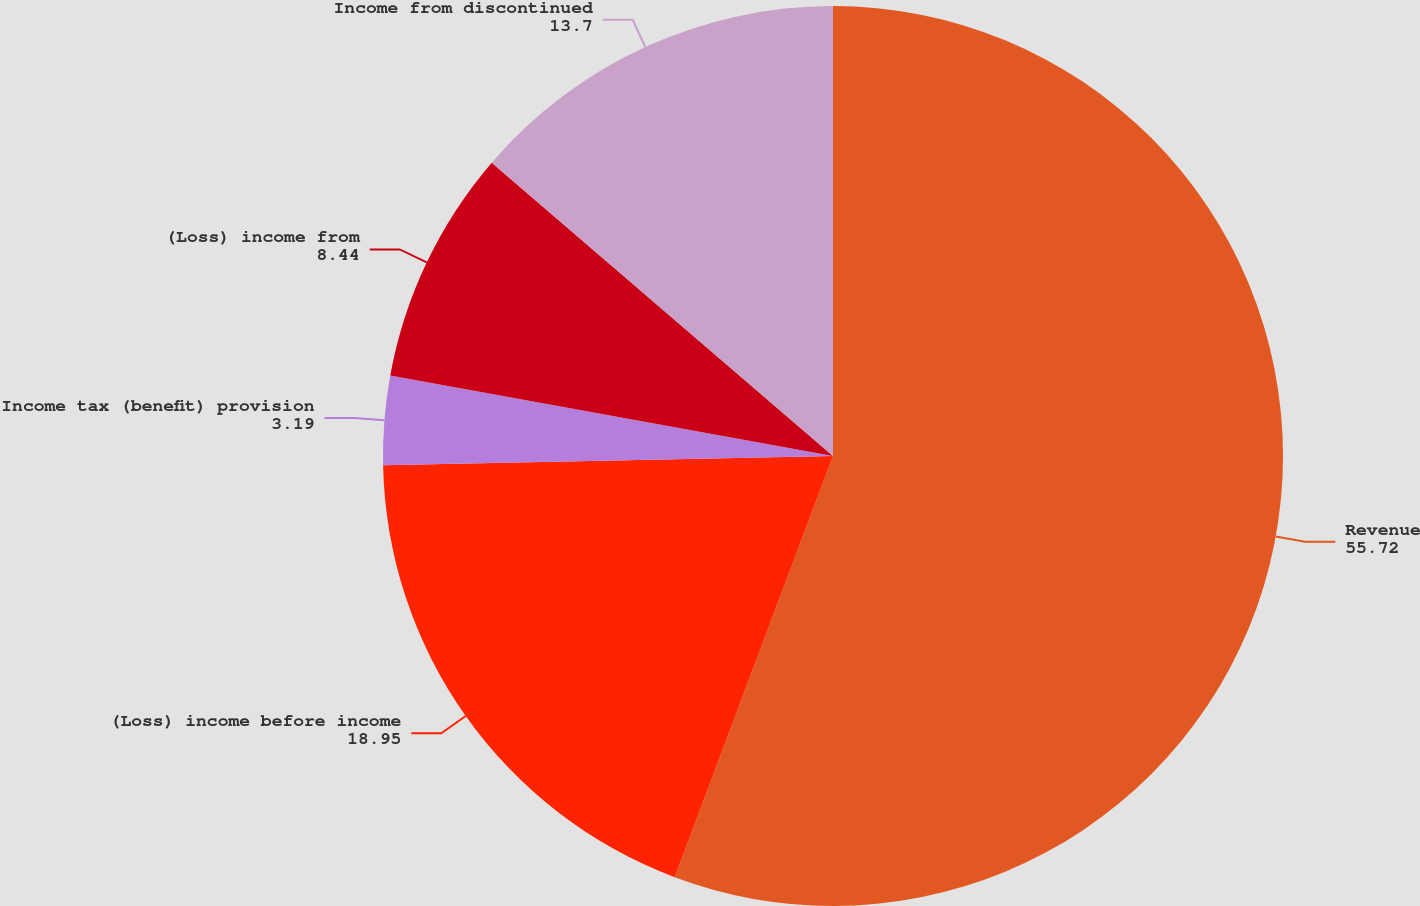<chart> <loc_0><loc_0><loc_500><loc_500><pie_chart><fcel>Revenue<fcel>(Loss) income before income<fcel>Income tax (benefit) provision<fcel>(Loss) income from<fcel>Income from discontinued<nl><fcel>55.72%<fcel>18.95%<fcel>3.19%<fcel>8.44%<fcel>13.7%<nl></chart> 